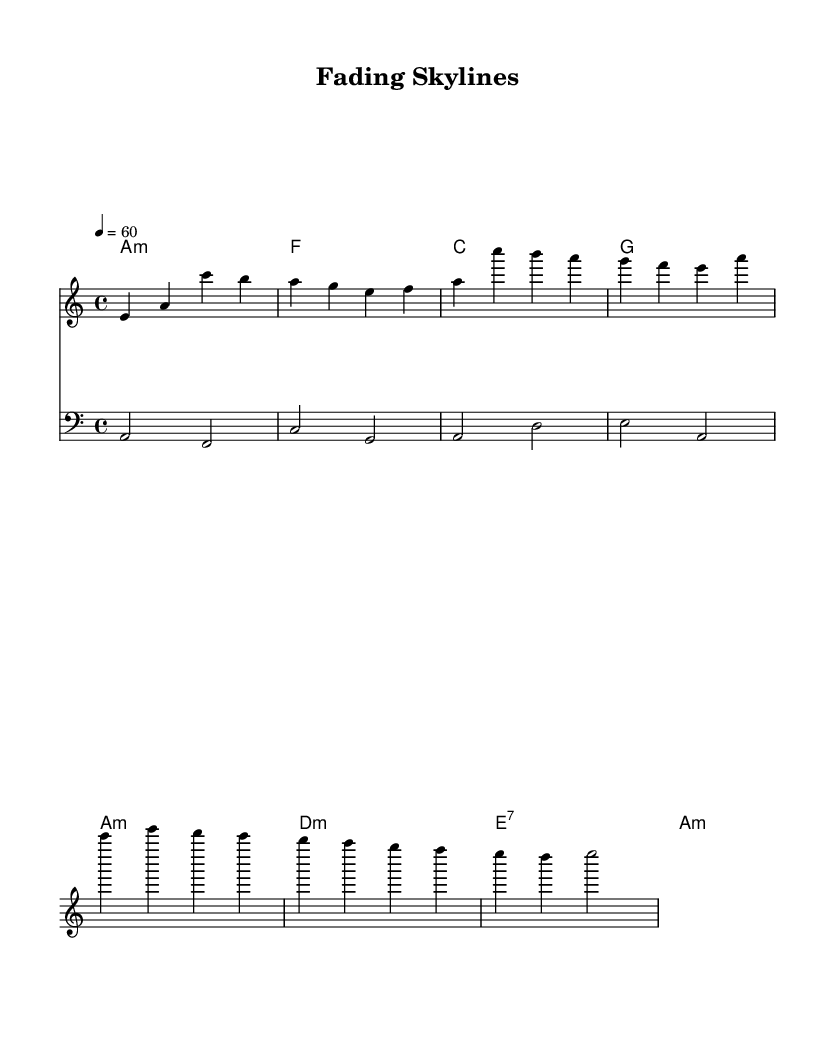What is the key signature of this music? The key signature is A minor, which has no sharps or flats. A minor is the relative minor of C major.
Answer: A minor What is the time signature of this piece? The time signature is found at the beginning of the score; it is 4/4, indicating four beats in a measure and a quarter note gets one beat.
Answer: 4/4 What is the tempo marking for this music? The tempo marking is indicated as "4 = 60," which means there should be 60 quarter note beats per minute.
Answer: 60 How many measures are in the melody? By counting the individual groups of notes separated by bar lines, the melody consists of 4 measures.
Answer: 4 What type of chord progression is used in the harmonies? Analyzing the chord changes, it shows a repeating pattern of minor and major chords that is typical in soul music, specifically following the pattern of A minor, F, C, G, and then D minor and E dominant seventh.
Answer: Minor and major Which note starts the melody? The first note in the melody is E, which is located at the start of the first measure.
Answer: E What is the last chord in the piece? The last chord indicated in the harmonies is A minor, which concludes the musical passage and ties back to the initial key signature.
Answer: A minor 